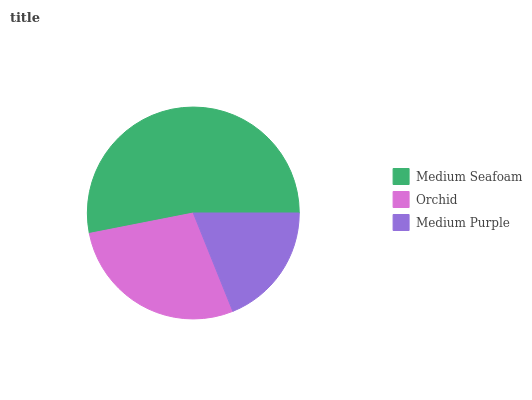Is Medium Purple the minimum?
Answer yes or no. Yes. Is Medium Seafoam the maximum?
Answer yes or no. Yes. Is Orchid the minimum?
Answer yes or no. No. Is Orchid the maximum?
Answer yes or no. No. Is Medium Seafoam greater than Orchid?
Answer yes or no. Yes. Is Orchid less than Medium Seafoam?
Answer yes or no. Yes. Is Orchid greater than Medium Seafoam?
Answer yes or no. No. Is Medium Seafoam less than Orchid?
Answer yes or no. No. Is Orchid the high median?
Answer yes or no. Yes. Is Orchid the low median?
Answer yes or no. Yes. Is Medium Purple the high median?
Answer yes or no. No. Is Medium Seafoam the low median?
Answer yes or no. No. 